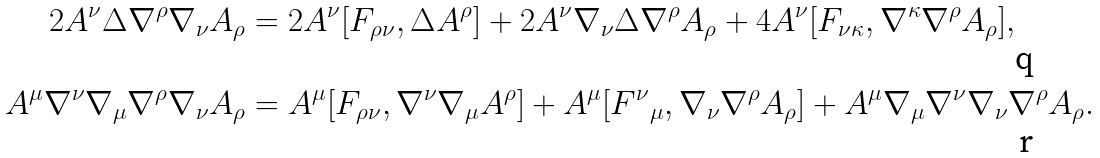Convert formula to latex. <formula><loc_0><loc_0><loc_500><loc_500>2 A ^ { \nu } \Delta \nabla ^ { \rho } \nabla _ { \nu } A _ { \rho } & = 2 A ^ { \nu } [ F _ { \rho \nu } , \Delta A ^ { \rho } ] + 2 A ^ { \nu } \nabla _ { \nu } \Delta \nabla ^ { \rho } A _ { \rho } + 4 A ^ { \nu } [ F _ { \nu \kappa } , \nabla ^ { \kappa } \nabla ^ { \rho } A _ { \rho } ] , \\ A ^ { \mu } \nabla ^ { \nu } \nabla _ { \mu } \nabla ^ { \rho } \nabla _ { \nu } A _ { \rho } & = A ^ { \mu } [ F _ { \rho \nu } , \nabla ^ { \nu } \nabla _ { \mu } A ^ { \rho } ] + A ^ { \mu } [ { F ^ { \nu } } _ { \mu } , \nabla _ { \nu } \nabla ^ { \rho } A _ { \rho } ] + A ^ { \mu } \nabla _ { \mu } \nabla ^ { \nu } \nabla _ { \nu } \nabla ^ { \rho } A _ { \rho } .</formula> 